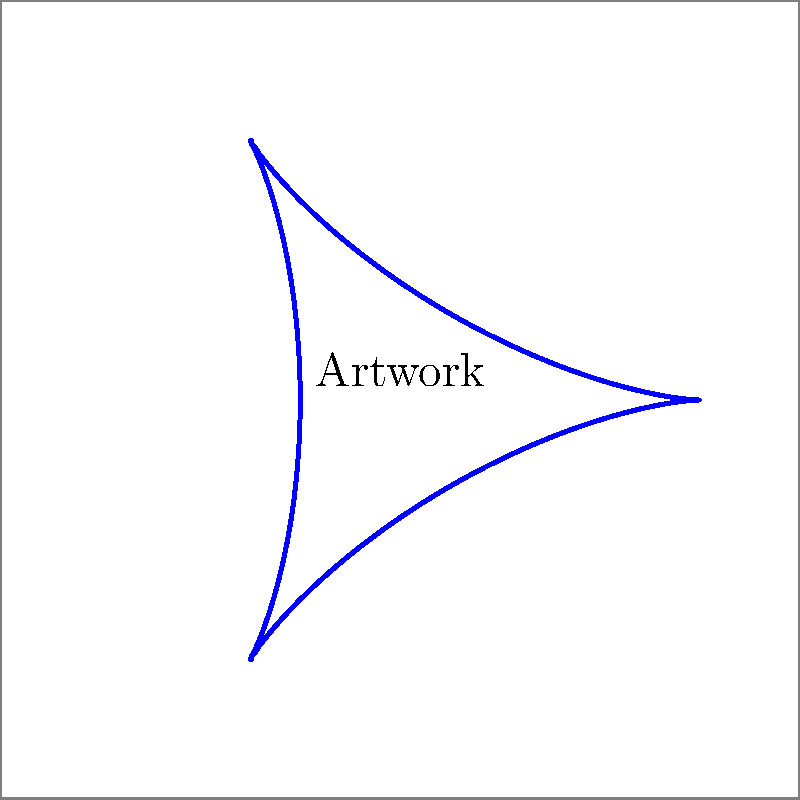As a curator, you've acquired an oddly-shaped artwork for your gallery. The artwork's outline follows the parametric equations:

$x(t) = \cos(t) + 0.5\cos(2t)$
$y(t) = \sin(t) - 0.5\sin(2t)$

where $0 \leq t \leq 2\pi$

To display this piece, you need to order a custom square frame. What should be the minimum side length of the square frame to fully enclose the artwork? To find the minimum side length of the square frame, we need to determine the maximum extent of the artwork in both x and y directions:

1) For the x-coordinate:
   $x(t) = \cos(t) + 0.5\cos(2t)$
   Maximum value occurs when both cosine terms are at their peak (1):
   $x_{max} = 1 + 0.5 = 1.5$
   Minimum value occurs when both cosine terms are at their lowest (-1):
   $x_{min} = -1 - 0.5 = -1.5$

2) For the y-coordinate:
   $y(t) = \sin(t) - 0.5\sin(2t)$
   Maximum value occurs when $\sin(t) = 1$ and $\sin(2t) = -1$:
   $y_{max} = 1 - (-0.5) = 1.5$
   Minimum value occurs when $\sin(t) = -1$ and $\sin(2t) = 1$:
   $y_{min} = -1 - 0.5 = -1.5$

3) The artwork extends from -1.5 to 1.5 in both x and y directions.

4) Therefore, the minimum side length of the square frame should be:
   $2 \times 1.5 = 3$ units

This will ensure that the frame fully encloses the artwork with the edges of the artwork just touching the frame at its extremities.
Answer: 3 units 